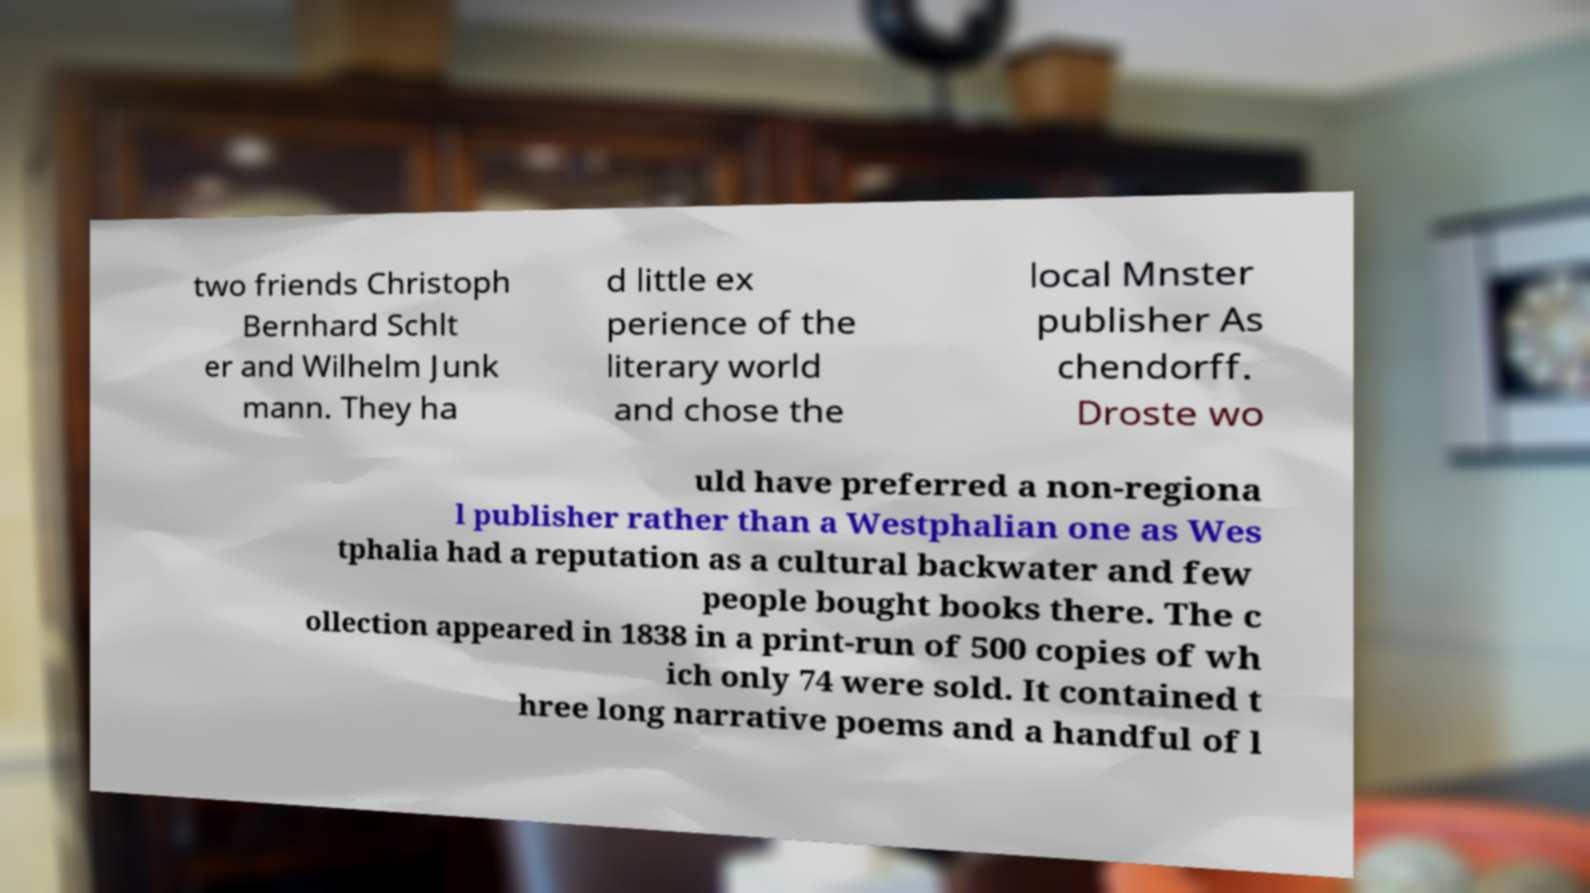What messages or text are displayed in this image? I need them in a readable, typed format. two friends Christoph Bernhard Schlt er and Wilhelm Junk mann. They ha d little ex perience of the literary world and chose the local Mnster publisher As chendorff. Droste wo uld have preferred a non-regiona l publisher rather than a Westphalian one as Wes tphalia had a reputation as a cultural backwater and few people bought books there. The c ollection appeared in 1838 in a print-run of 500 copies of wh ich only 74 were sold. It contained t hree long narrative poems and a handful of l 